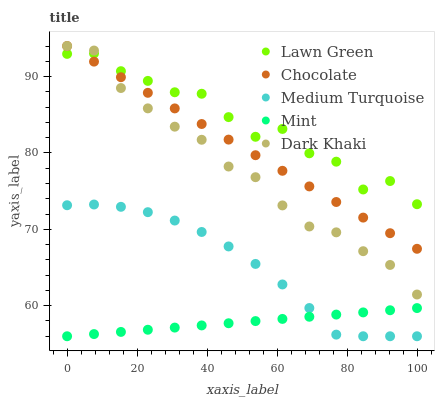Does Mint have the minimum area under the curve?
Answer yes or no. Yes. Does Lawn Green have the maximum area under the curve?
Answer yes or no. Yes. Does Lawn Green have the minimum area under the curve?
Answer yes or no. No. Does Mint have the maximum area under the curve?
Answer yes or no. No. Is Chocolate the smoothest?
Answer yes or no. Yes. Is Lawn Green the roughest?
Answer yes or no. Yes. Is Mint the smoothest?
Answer yes or no. No. Is Mint the roughest?
Answer yes or no. No. Does Mint have the lowest value?
Answer yes or no. Yes. Does Lawn Green have the lowest value?
Answer yes or no. No. Does Chocolate have the highest value?
Answer yes or no. Yes. Does Lawn Green have the highest value?
Answer yes or no. No. Is Medium Turquoise less than Dark Khaki?
Answer yes or no. Yes. Is Lawn Green greater than Medium Turquoise?
Answer yes or no. Yes. Does Chocolate intersect Dark Khaki?
Answer yes or no. Yes. Is Chocolate less than Dark Khaki?
Answer yes or no. No. Is Chocolate greater than Dark Khaki?
Answer yes or no. No. Does Medium Turquoise intersect Dark Khaki?
Answer yes or no. No. 